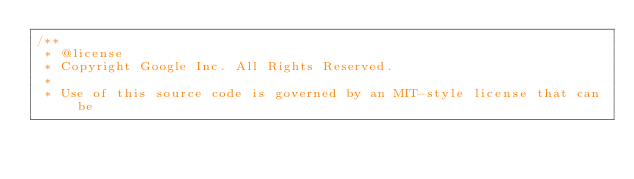Convert code to text. <code><loc_0><loc_0><loc_500><loc_500><_TypeScript_>/**
 * @license
 * Copyright Google Inc. All Rights Reserved.
 *
 * Use of this source code is governed by an MIT-style license that can be</code> 